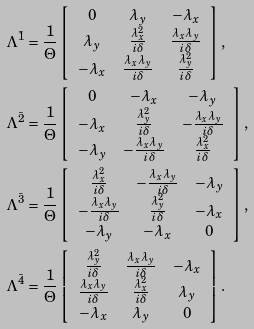<formula> <loc_0><loc_0><loc_500><loc_500>& \Lambda ^ { \bar { 1 } } = \frac { 1 } { \Theta } \left [ \begin{array} { c c c } 0 & \lambda _ { y } & - \lambda _ { x } \\ \lambda _ { y } & \frac { \lambda _ { x } ^ { 2 } } { i \delta } & \frac { \lambda _ { x } \lambda _ { y } } { i \delta } \\ - \lambda _ { x } & \frac { \lambda _ { x } \lambda _ { y } } { i \delta } & \frac { \lambda _ { y } ^ { 2 } } { i \delta } \\ \end{array} \right ] , \\ & \Lambda ^ { \bar { 2 } } = \frac { 1 } { \Theta } \left [ \begin{array} { c c c } 0 & - \lambda _ { x } & - \lambda _ { y } \\ - \lambda _ { x } & \frac { \lambda _ { y } ^ { 2 } } { i \delta } & - \frac { \lambda _ { x } \lambda _ { y } } { i \delta } \\ - \lambda _ { y } & - \frac { \lambda _ { x } \lambda _ { y } } { i \delta } & \frac { \lambda _ { x } ^ { 2 } } { i \delta } \\ \end{array} \right ] , \\ & \Lambda ^ { \bar { 3 } } = \frac { 1 } { \Theta } \left [ \begin{array} { c c c } \frac { \lambda _ { x } ^ { 2 } } { i \delta } & - \frac { \lambda _ { x } \lambda _ { y } } { i \delta } & - \lambda _ { y } \\ - \frac { \lambda _ { x } \lambda _ { y } } { i \delta } & \frac { \lambda _ { y } ^ { 2 } } { i \delta } & - \lambda _ { x } \\ - \lambda _ { y } & - \lambda _ { x } & 0 \\ \end{array} \right ] , \\ & \Lambda ^ { \bar { 4 } } = \frac { 1 } { \Theta } \left [ \begin{array} { c c c } \frac { \lambda _ { y } ^ { 2 } } { i \delta } & \frac { \lambda _ { x } \lambda _ { y } } { i \delta } & - \lambda _ { x } \\ \frac { \lambda _ { x } \lambda _ { y } } { i \delta } & \frac { \lambda _ { x } ^ { 2 } } { i \delta } & \lambda _ { y } \\ - \lambda _ { x } & \lambda _ { y } & 0 \\ \end{array} \right ] .</formula> 